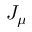<formula> <loc_0><loc_0><loc_500><loc_500>J _ { \mu }</formula> 